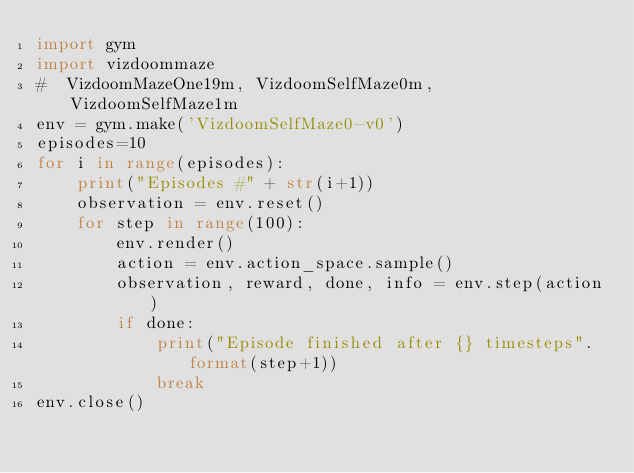<code> <loc_0><loc_0><loc_500><loc_500><_Python_>import gym
import vizdoommaze
#  VizdoomMazeOne19m, VizdoomSelfMaze0m, VizdoomSelfMaze1m
env = gym.make('VizdoomSelfMaze0-v0')
episodes=10
for i in range(episodes):
    print("Episodes #" + str(i+1))
    observation = env.reset()
    for step in range(100):
        env.render()
        action = env.action_space.sample()
        observation, reward, done, info = env.step(action)
        if done:
            print("Episode finished after {} timesteps".format(step+1))
            break
env.close()
</code> 